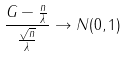Convert formula to latex. <formula><loc_0><loc_0><loc_500><loc_500>\frac { G - \frac { n } { \lambda } } { \frac { \sqrt { n } } { \lambda } } \rightarrow N ( 0 , 1 )</formula> 